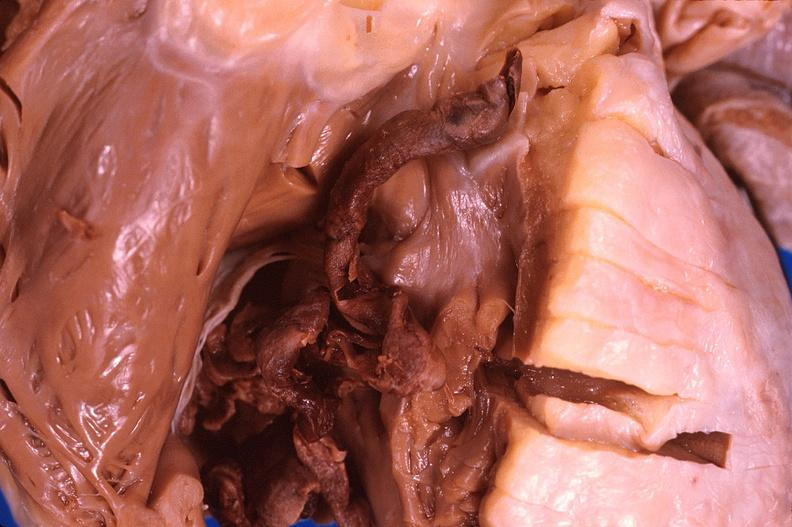s retroperitoneum present?
Answer the question using a single word or phrase. No 